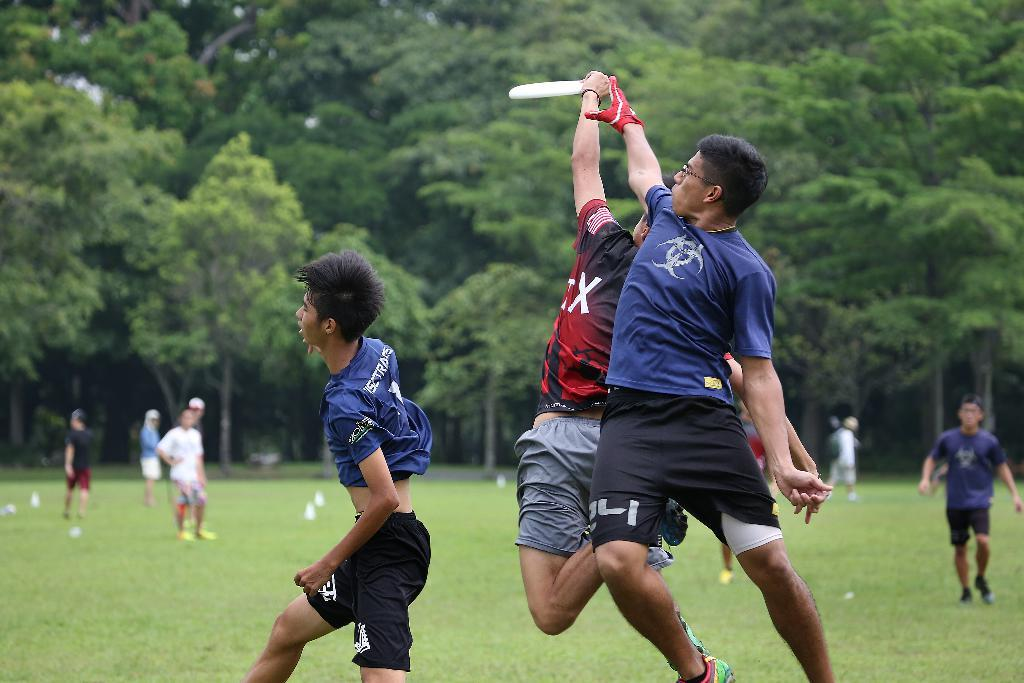How many people are present in the image? There are three people in the image. What is one person doing in the image? One person is holding an object. Can you describe the people in the background? There is a group of people in the background, and they are on the ground. What can be seen in the background besides the group of people? Trees are visible in the background. What type of health benefits can be gained from the object the person is holding in the image? There is no information about the object's health benefits in the image, as the focus is on the number of people and their actions. 